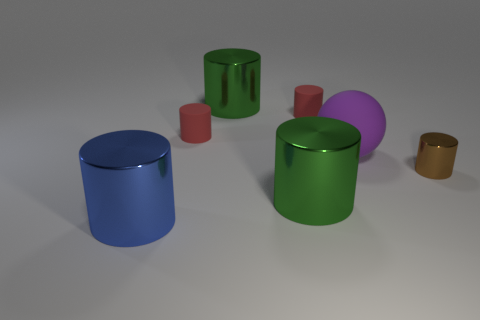There is a green shiny object to the right of the large green metallic cylinder behind the small brown thing; how many green metallic things are behind it?
Offer a terse response. 1. There is a green cylinder that is behind the purple thing behind the brown cylinder; what is its size?
Offer a terse response. Large. There is a blue cylinder that is the same material as the small brown thing; what size is it?
Offer a very short reply. Large. There is a big object that is both behind the small metallic cylinder and on the left side of the large purple matte object; what is its shape?
Keep it short and to the point. Cylinder. Is the number of brown metal objects left of the blue metallic object the same as the number of tiny blue matte cylinders?
Give a very brief answer. Yes. How many things are tiny matte balls or large green metallic cylinders that are in front of the large sphere?
Provide a short and direct response. 1. Are there any small red rubber objects that have the same shape as the small brown metal object?
Your response must be concise. Yes. Is the number of small shiny cylinders that are to the right of the brown cylinder the same as the number of big things that are to the left of the blue metal cylinder?
Provide a succinct answer. Yes. Are there any other things that have the same size as the purple thing?
Your answer should be very brief. Yes. What number of yellow things are matte objects or small matte cylinders?
Ensure brevity in your answer.  0. 